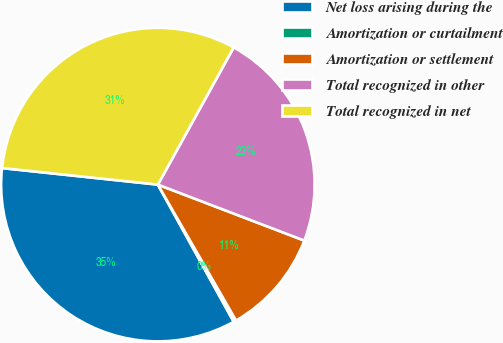<chart> <loc_0><loc_0><loc_500><loc_500><pie_chart><fcel>Net loss arising during the<fcel>Amortization or curtailment<fcel>Amortization or settlement<fcel>Total recognized in other<fcel>Total recognized in net<nl><fcel>34.72%<fcel>0.27%<fcel>10.88%<fcel>22.78%<fcel>31.35%<nl></chart> 